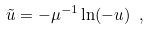<formula> <loc_0><loc_0><loc_500><loc_500>\tilde { u } = - \mu ^ { - 1 } \ln ( - u ) \ ,</formula> 